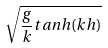<formula> <loc_0><loc_0><loc_500><loc_500>\sqrt { \frac { g } { k } t a n h ( k h ) }</formula> 